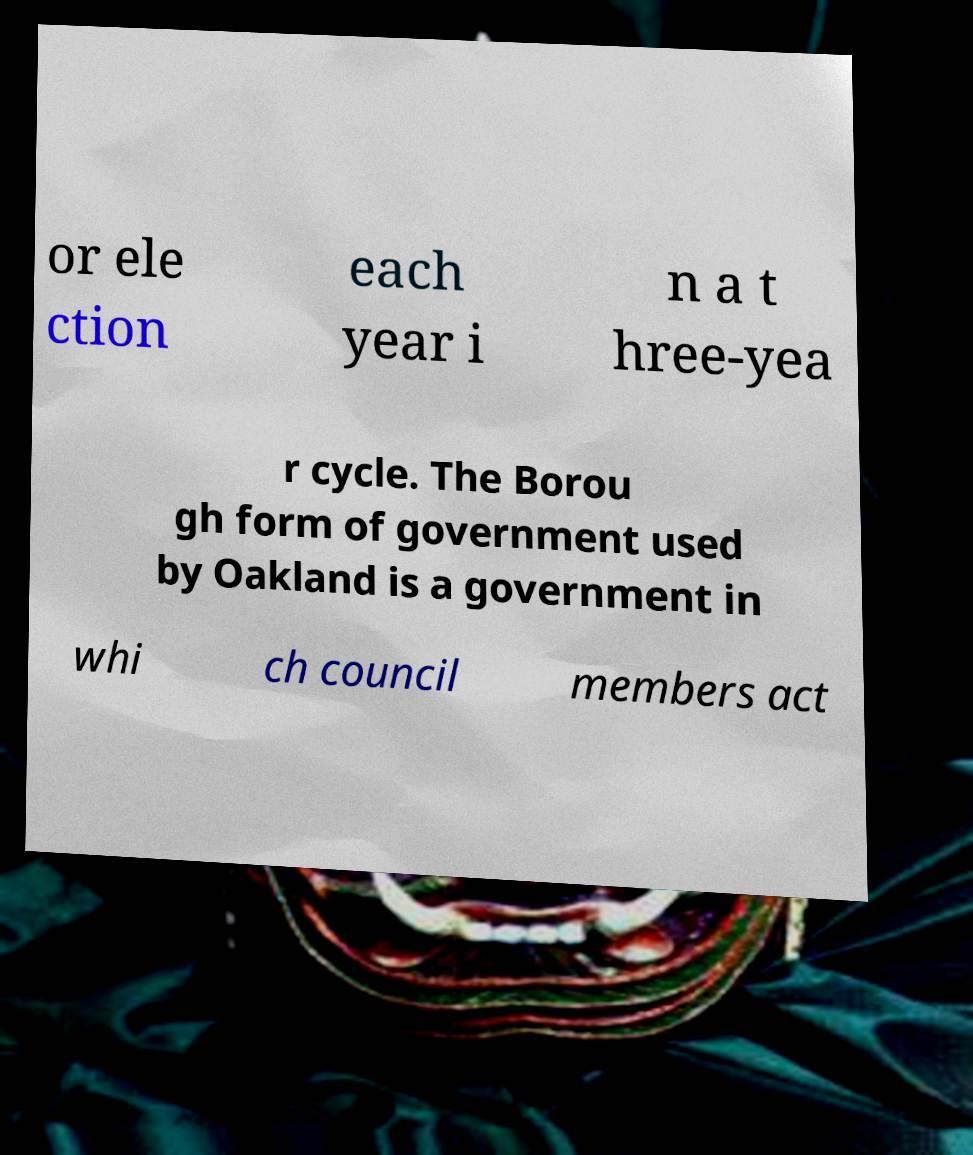Could you extract and type out the text from this image? or ele ction each year i n a t hree-yea r cycle. The Borou gh form of government used by Oakland is a government in whi ch council members act 